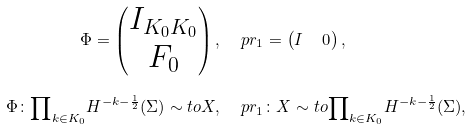<formula> <loc_0><loc_0><loc_500><loc_500>\Phi = \begin{pmatrix} I _ { K _ { 0 } K _ { 0 } } \\ F _ { 0 } \end{pmatrix} , & \quad \ p r _ { 1 } = \begin{pmatrix} I & \, 0 \end{pmatrix} , \\ \Phi \colon { \prod } _ { k \in K _ { 0 } } H ^ { - k - \frac { 1 } { 2 } } ( \Sigma ) \sim t o X , & \quad \ p r _ { 1 } \colon X \sim t o { \prod } _ { k \in K _ { 0 } } H ^ { - k - \frac { 1 } { 2 } } ( \Sigma ) ,</formula> 